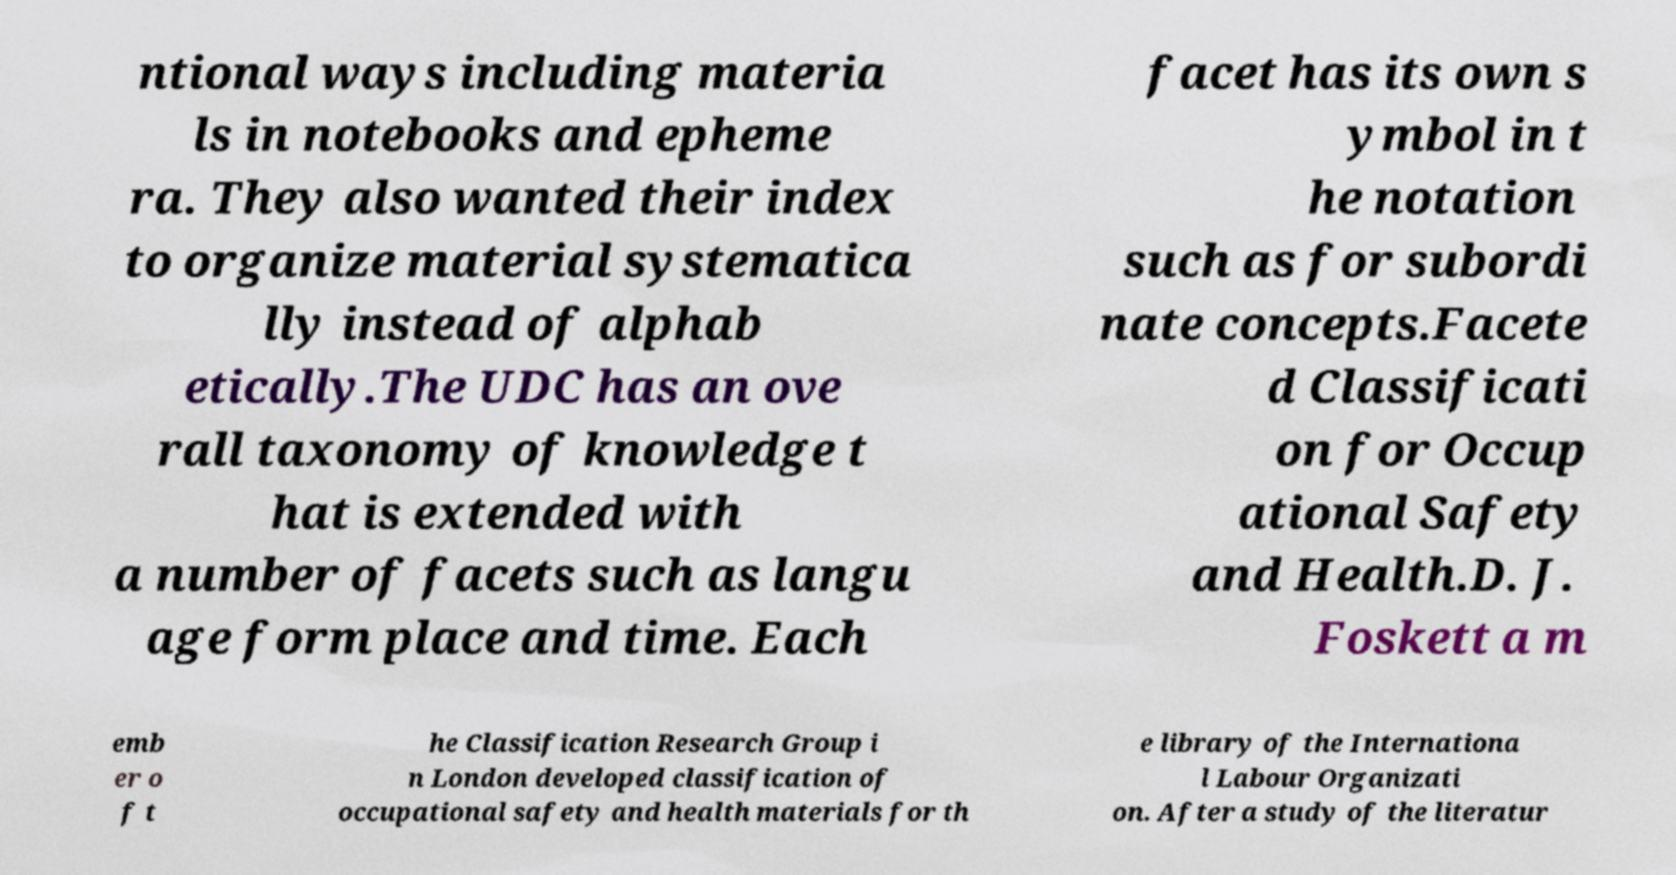Please read and relay the text visible in this image. What does it say? ntional ways including materia ls in notebooks and epheme ra. They also wanted their index to organize material systematica lly instead of alphab etically.The UDC has an ove rall taxonomy of knowledge t hat is extended with a number of facets such as langu age form place and time. Each facet has its own s ymbol in t he notation such as for subordi nate concepts.Facete d Classificati on for Occup ational Safety and Health.D. J. Foskett a m emb er o f t he Classification Research Group i n London developed classification of occupational safety and health materials for th e library of the Internationa l Labour Organizati on. After a study of the literatur 